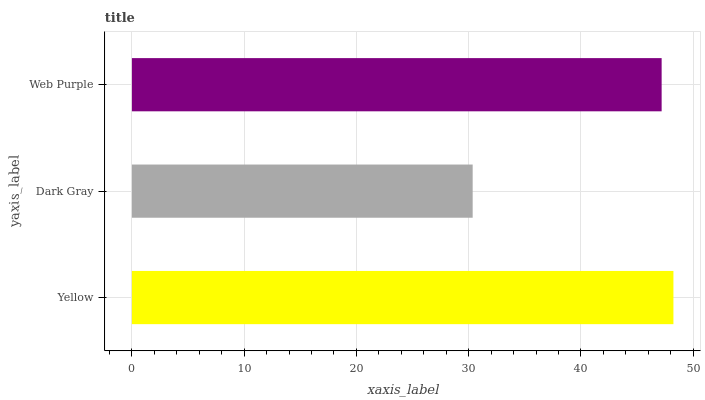Is Dark Gray the minimum?
Answer yes or no. Yes. Is Yellow the maximum?
Answer yes or no. Yes. Is Web Purple the minimum?
Answer yes or no. No. Is Web Purple the maximum?
Answer yes or no. No. Is Web Purple greater than Dark Gray?
Answer yes or no. Yes. Is Dark Gray less than Web Purple?
Answer yes or no. Yes. Is Dark Gray greater than Web Purple?
Answer yes or no. No. Is Web Purple less than Dark Gray?
Answer yes or no. No. Is Web Purple the high median?
Answer yes or no. Yes. Is Web Purple the low median?
Answer yes or no. Yes. Is Yellow the high median?
Answer yes or no. No. Is Yellow the low median?
Answer yes or no. No. 